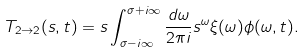<formula> <loc_0><loc_0><loc_500><loc_500>T _ { 2 \to 2 } ( s , t ) = s \int _ { \sigma - i \infty } ^ { \sigma + i \infty } \frac { d \omega } { 2 \pi i } s ^ { \omega } \xi ( \omega ) \phi ( \omega , t ) .</formula> 